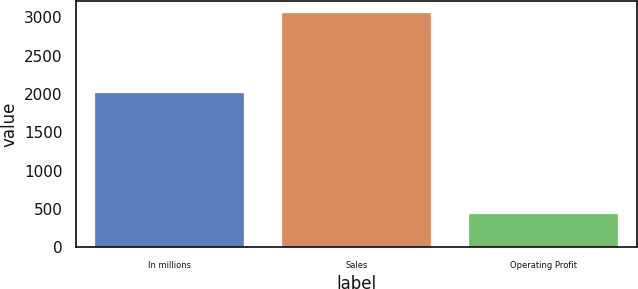Convert chart. <chart><loc_0><loc_0><loc_500><loc_500><bar_chart><fcel>In millions<fcel>Sales<fcel>Operating Profit<nl><fcel>2009<fcel>3060<fcel>433<nl></chart> 